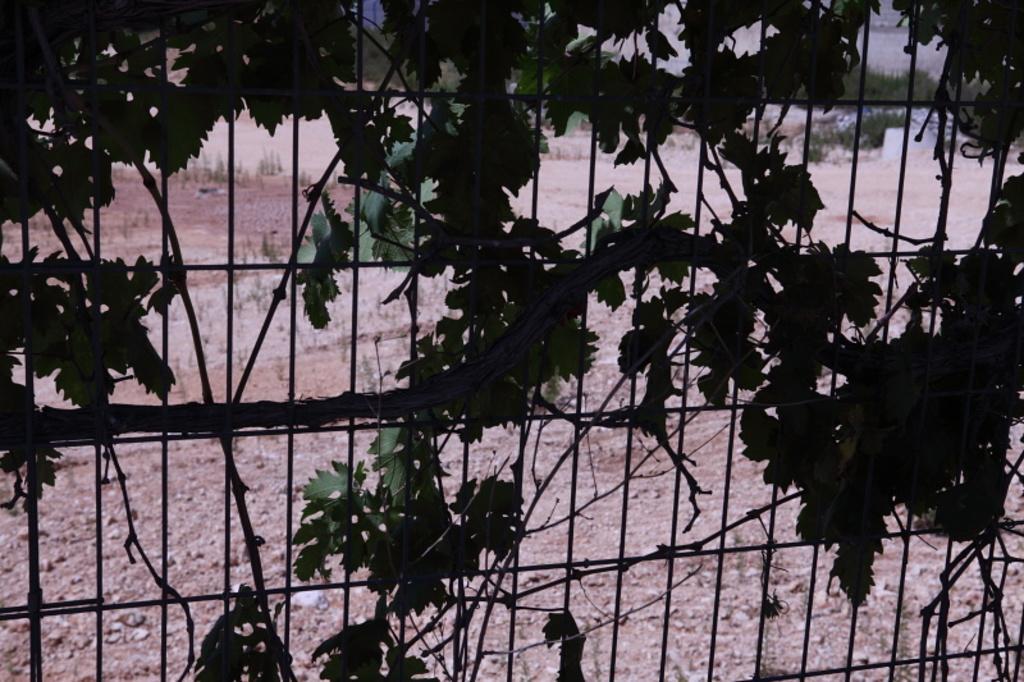How would you summarize this image in a sentence or two? In this image I can see the bushes to the railing. In the back I can see the ground and plants. 